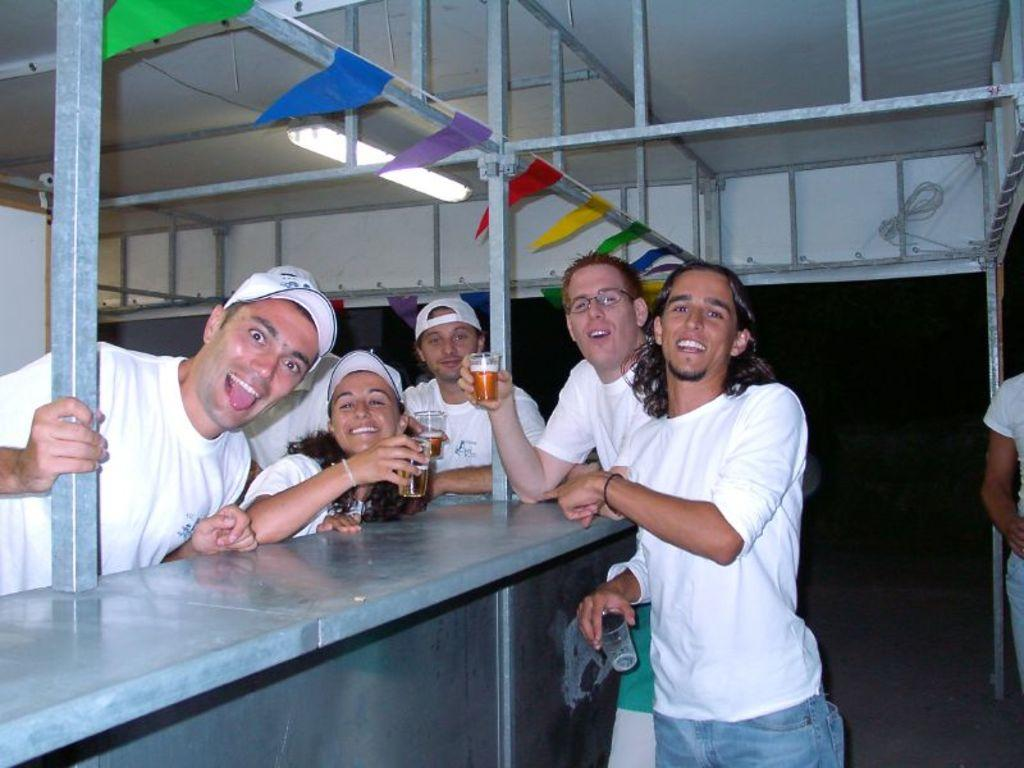Who is present in the image? There are people in the image. What is the facial expression of the people in the image? The people are smiling. What are the people wearing in the image? The people are wearing white t-shirts. What are some people holding in the image? Some people are holding wine glasses in their hands. What month is it in the image? The month is not mentioned or depicted in the image, so it cannot be determined. 